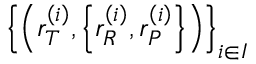Convert formula to latex. <formula><loc_0><loc_0><loc_500><loc_500>\left \{ \left ( r _ { T } ^ { \left ( i \right ) } , \left \{ r _ { R } ^ { \left ( i \right ) } , r _ { P } ^ { \left ( i \right ) } \right \} \right ) \right \} _ { i \in I }</formula> 